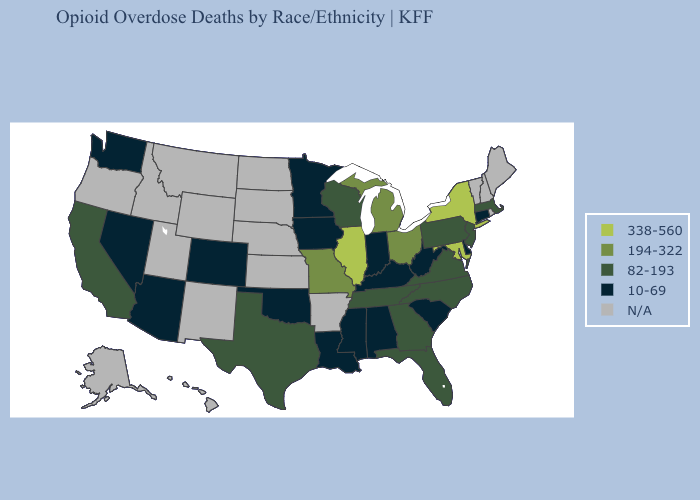Name the states that have a value in the range N/A?
Concise answer only. Alaska, Arkansas, Hawaii, Idaho, Kansas, Maine, Montana, Nebraska, New Hampshire, New Mexico, North Dakota, Oregon, Rhode Island, South Dakota, Utah, Vermont, Wyoming. Name the states that have a value in the range 82-193?
Concise answer only. California, Florida, Georgia, Massachusetts, New Jersey, North Carolina, Pennsylvania, Tennessee, Texas, Virginia, Wisconsin. Name the states that have a value in the range 82-193?
Write a very short answer. California, Florida, Georgia, Massachusetts, New Jersey, North Carolina, Pennsylvania, Tennessee, Texas, Virginia, Wisconsin. What is the value of Delaware?
Keep it brief. 10-69. Does the first symbol in the legend represent the smallest category?
Short answer required. No. Name the states that have a value in the range 10-69?
Concise answer only. Alabama, Arizona, Colorado, Connecticut, Delaware, Indiana, Iowa, Kentucky, Louisiana, Minnesota, Mississippi, Nevada, Oklahoma, South Carolina, Washington, West Virginia. Does California have the highest value in the West?
Give a very brief answer. Yes. Does the first symbol in the legend represent the smallest category?
Quick response, please. No. What is the value of North Dakota?
Keep it brief. N/A. Is the legend a continuous bar?
Write a very short answer. No. How many symbols are there in the legend?
Write a very short answer. 5. What is the value of Mississippi?
Write a very short answer. 10-69. 